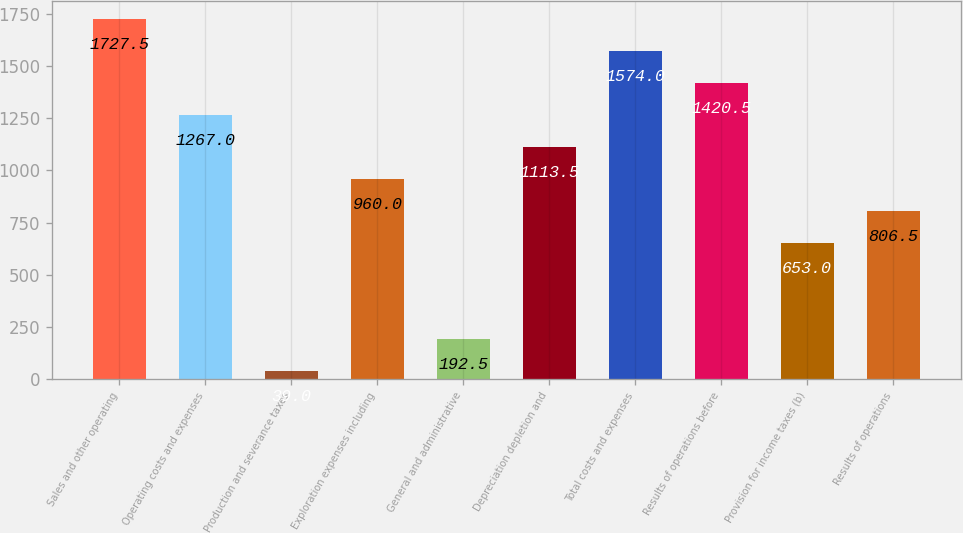Convert chart. <chart><loc_0><loc_0><loc_500><loc_500><bar_chart><fcel>Sales and other operating<fcel>Operating costs and expenses<fcel>Production and severance taxes<fcel>Exploration expenses including<fcel>General and administrative<fcel>Depreciation depletion and<fcel>Total costs and expenses<fcel>Results of operations before<fcel>Provision for income taxes (b)<fcel>Results of operations<nl><fcel>1727.5<fcel>1267<fcel>39<fcel>960<fcel>192.5<fcel>1113.5<fcel>1574<fcel>1420.5<fcel>653<fcel>806.5<nl></chart> 